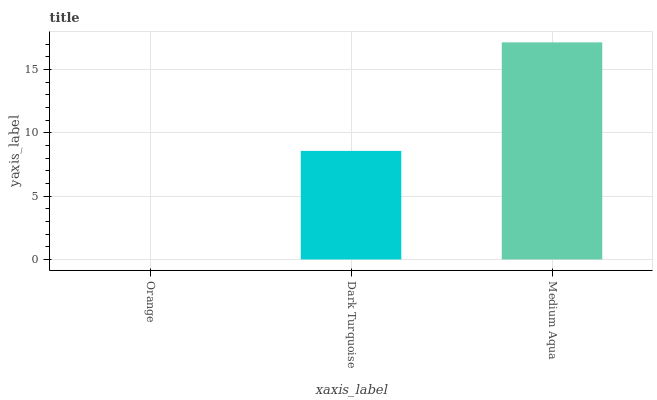Is Dark Turquoise the minimum?
Answer yes or no. No. Is Dark Turquoise the maximum?
Answer yes or no. No. Is Dark Turquoise greater than Orange?
Answer yes or no. Yes. Is Orange less than Dark Turquoise?
Answer yes or no. Yes. Is Orange greater than Dark Turquoise?
Answer yes or no. No. Is Dark Turquoise less than Orange?
Answer yes or no. No. Is Dark Turquoise the high median?
Answer yes or no. Yes. Is Dark Turquoise the low median?
Answer yes or no. Yes. Is Orange the high median?
Answer yes or no. No. Is Orange the low median?
Answer yes or no. No. 